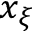Convert formula to latex. <formula><loc_0><loc_0><loc_500><loc_500>x _ { \xi }</formula> 